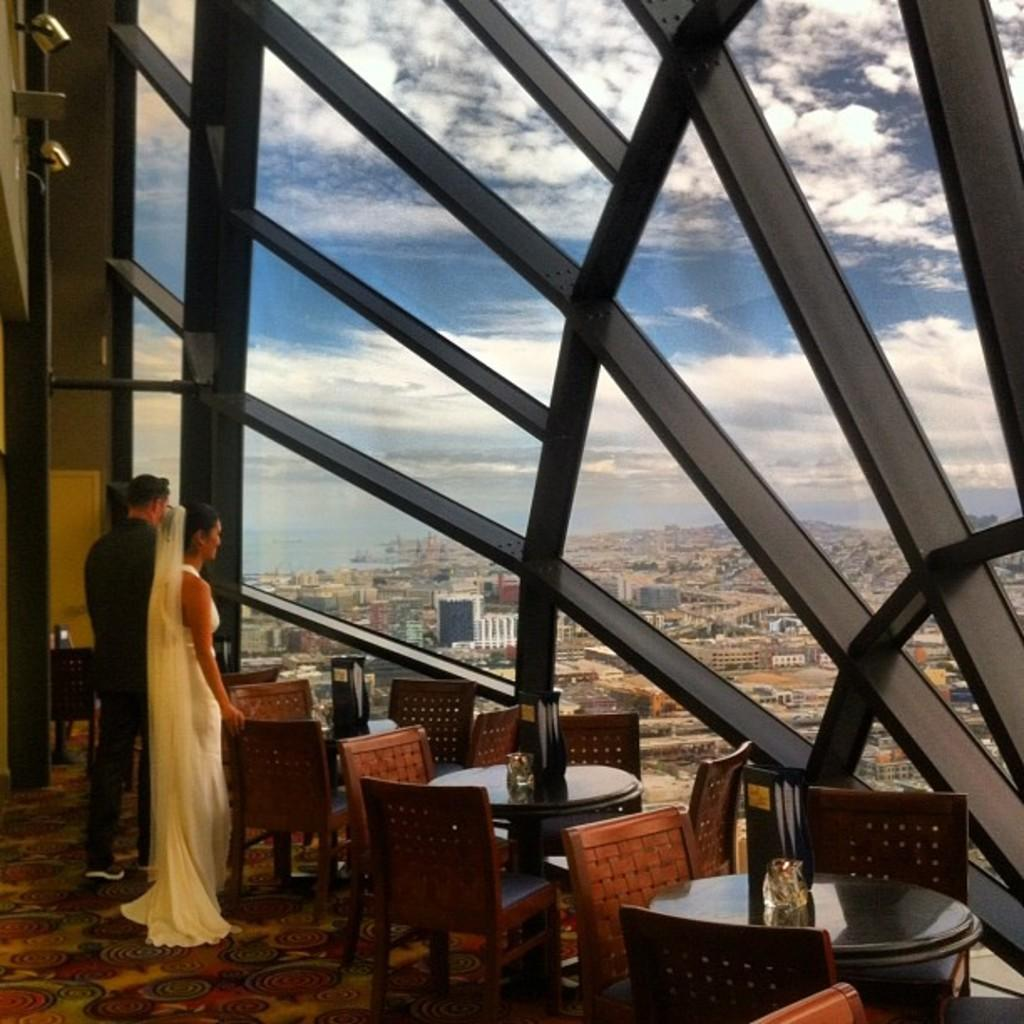Who are the people in the image? There is a man and a woman in the image. What are the man and woman wearing? The man is wearing a gown, and the woman is wearing a gown and a veil. What furniture is present in front of the man and woman? There are chairs and tables in front of the man and woman. What can be seen in the background of the image? There are buildings and the sky visible in the background of the image. What type of beginner's rifle is visible in the image? There is no rifle present in the image. What idea does the man have for the woman's gown? There is no indication in the image of any ideas or discussions about the gowns. 